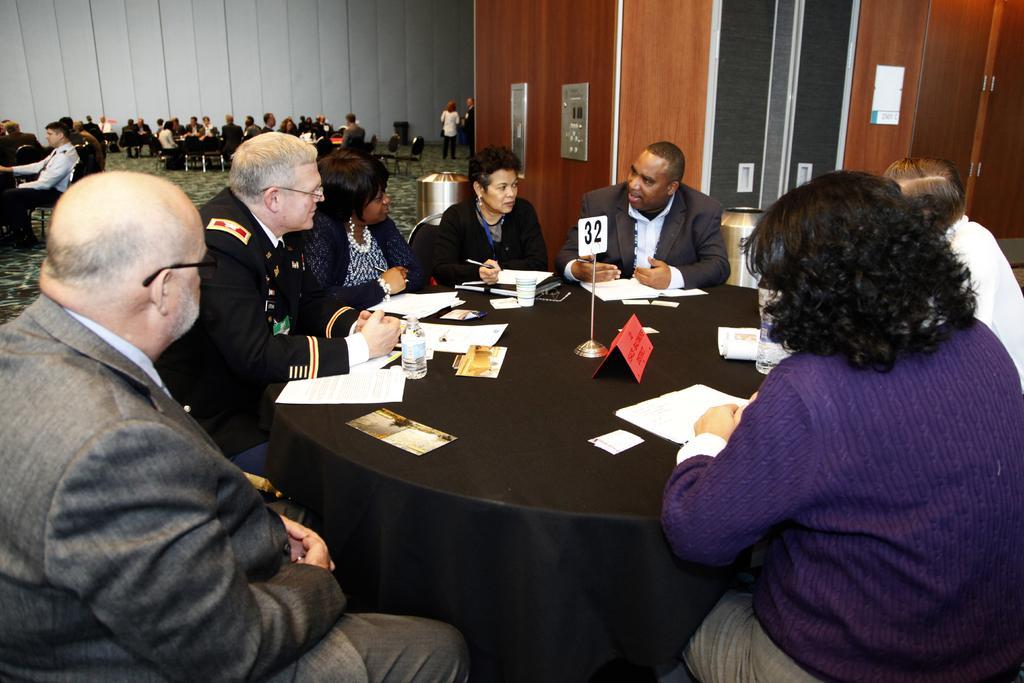Could you give a brief overview of what you see in this image? This picture shows a group of people seated on the chairś and we see few papers on the table and we see few groupś seated on the chairs and a couple of them are standing 